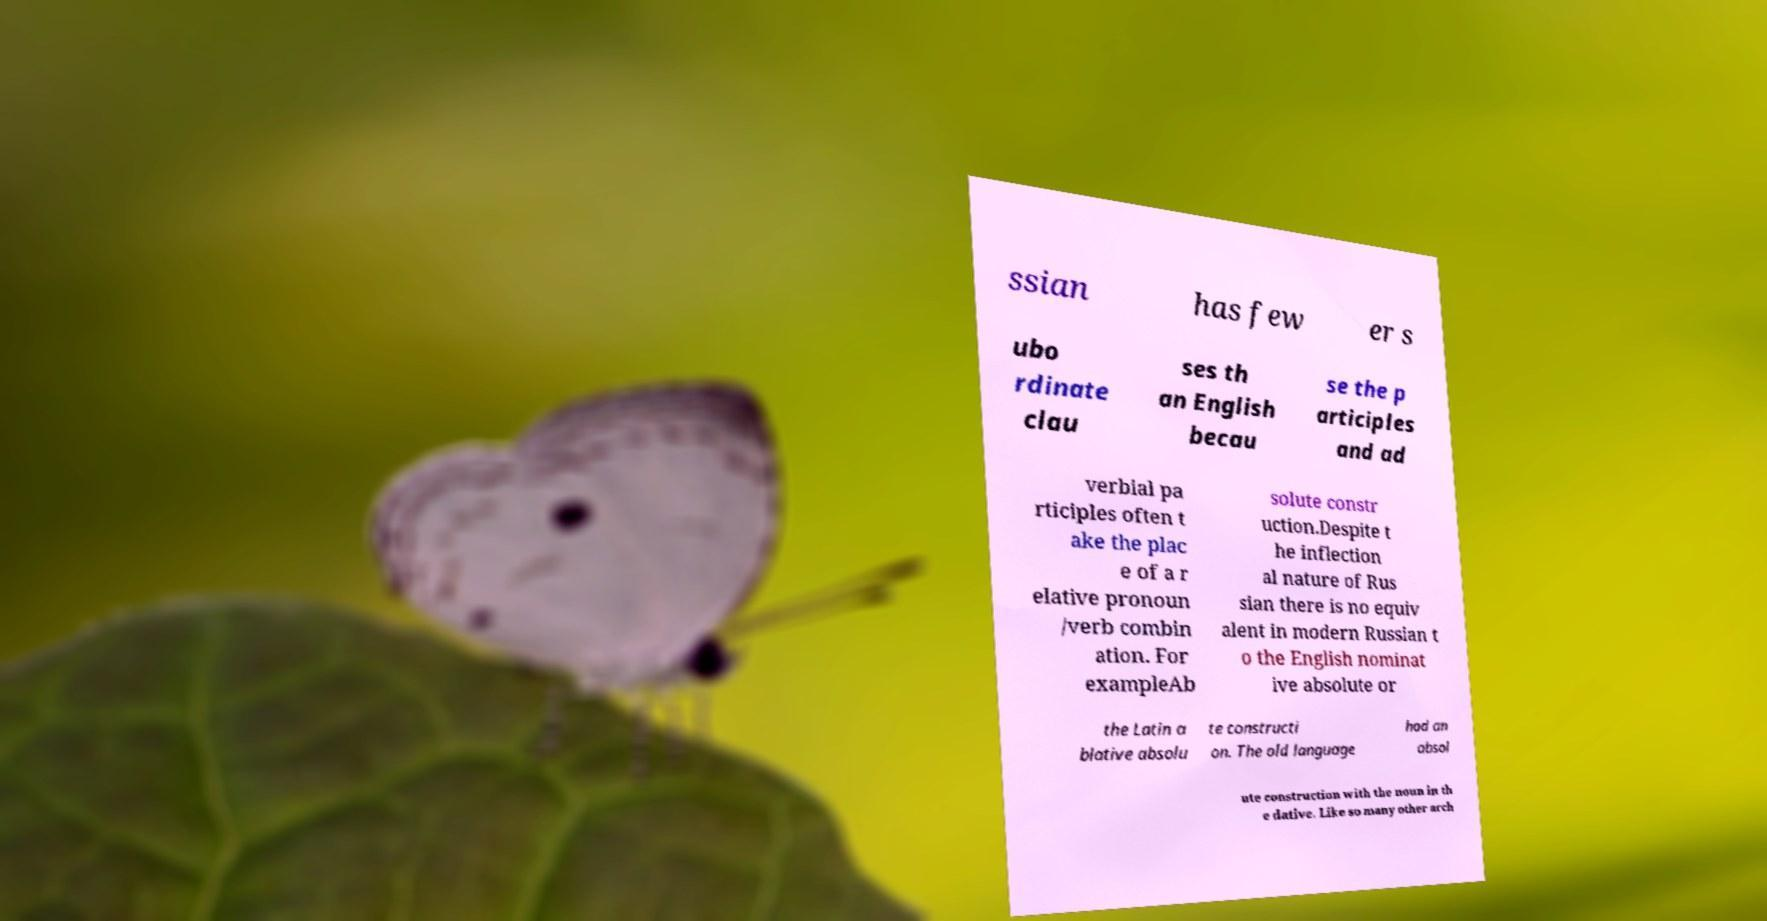Could you extract and type out the text from this image? ssian has few er s ubo rdinate clau ses th an English becau se the p articiples and ad verbial pa rticiples often t ake the plac e of a r elative pronoun /verb combin ation. For exampleAb solute constr uction.Despite t he inflection al nature of Rus sian there is no equiv alent in modern Russian t o the English nominat ive absolute or the Latin a blative absolu te constructi on. The old language had an absol ute construction with the noun in th e dative. Like so many other arch 